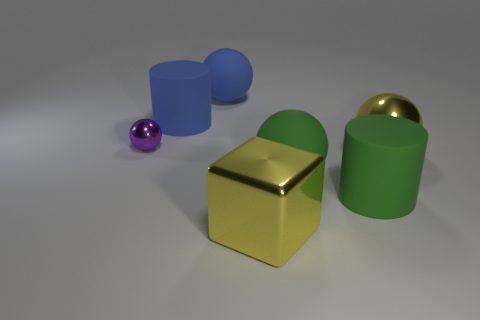Are there fewer green cylinders than big metallic objects?
Give a very brief answer. Yes. There is a green rubber object that is the same shape as the purple thing; what is its size?
Provide a succinct answer. Large. Do the large sphere behind the small metallic object and the green sphere have the same material?
Your answer should be compact. Yes. How many things are either objects that are on the right side of the blue cylinder or small purple metal cylinders?
Offer a very short reply. 5. There is another cylinder that is the same material as the blue cylinder; what is its size?
Ensure brevity in your answer.  Large. How many tiny metallic spheres have the same color as the large shiny block?
Your response must be concise. 0. How many big objects are blue cylinders or spheres?
Your answer should be very brief. 4. What is the size of the metallic sphere that is the same color as the large block?
Ensure brevity in your answer.  Large. Is there a green cylinder that has the same material as the yellow cube?
Ensure brevity in your answer.  No. There is a cylinder that is behind the tiny metal thing; what is its material?
Offer a very short reply. Rubber. 